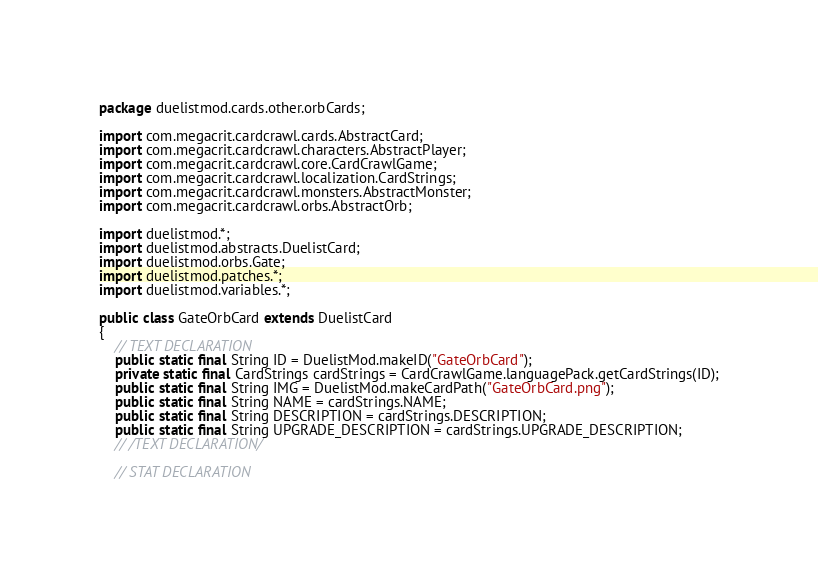Convert code to text. <code><loc_0><loc_0><loc_500><loc_500><_Java_>package duelistmod.cards.other.orbCards;

import com.megacrit.cardcrawl.cards.AbstractCard;
import com.megacrit.cardcrawl.characters.AbstractPlayer;
import com.megacrit.cardcrawl.core.CardCrawlGame;
import com.megacrit.cardcrawl.localization.CardStrings;
import com.megacrit.cardcrawl.monsters.AbstractMonster;
import com.megacrit.cardcrawl.orbs.AbstractOrb;

import duelistmod.*;
import duelistmod.abstracts.DuelistCard;
import duelistmod.orbs.Gate;
import duelistmod.patches.*;
import duelistmod.variables.*;

public class GateOrbCard extends DuelistCard 
{
    // TEXT DECLARATION
    public static final String ID = DuelistMod.makeID("GateOrbCard");
    private static final CardStrings cardStrings = CardCrawlGame.languagePack.getCardStrings(ID);
    public static final String IMG = DuelistMod.makeCardPath("GateOrbCard.png");
    public static final String NAME = cardStrings.NAME;
    public static final String DESCRIPTION = cardStrings.DESCRIPTION;
    public static final String UPGRADE_DESCRIPTION = cardStrings.UPGRADE_DESCRIPTION;
    // /TEXT DECLARATION/

    // STAT DECLARATION</code> 